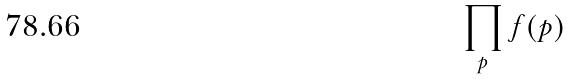Convert formula to latex. <formula><loc_0><loc_0><loc_500><loc_500>\prod _ { p } f ( p )</formula> 